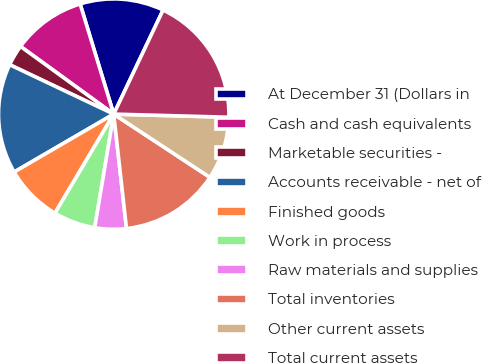Convert chart. <chart><loc_0><loc_0><loc_500><loc_500><pie_chart><fcel>At December 31 (Dollars in<fcel>Cash and cash equivalents<fcel>Marketable securities -<fcel>Accounts receivable - net of<fcel>Finished goods<fcel>Work in process<fcel>Raw materials and supplies<fcel>Total inventories<fcel>Other current assets<fcel>Total current assets<nl><fcel>11.76%<fcel>10.29%<fcel>2.94%<fcel>15.44%<fcel>8.09%<fcel>5.88%<fcel>4.41%<fcel>13.97%<fcel>8.82%<fcel>18.38%<nl></chart> 